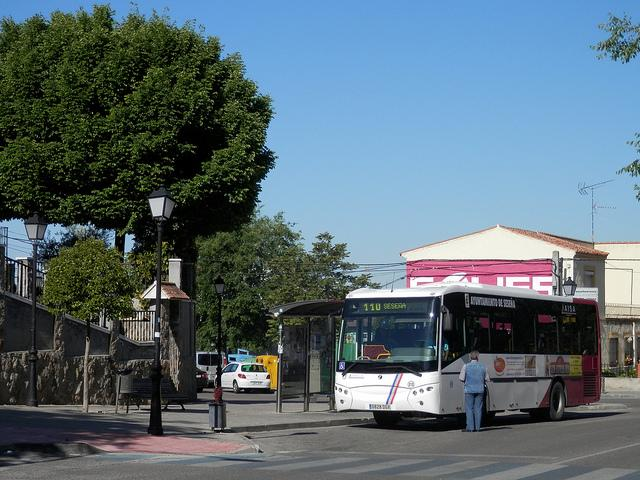During which weather would the bus stop here be most appreciated by riders? Please explain your reasoning. rain. The stop has a roof covering. 